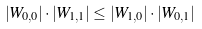<formula> <loc_0><loc_0><loc_500><loc_500>| W _ { 0 , 0 } | \cdot | W _ { 1 , 1 } | \leq | W _ { 1 , 0 } | \cdot | W _ { 0 , 1 } |</formula> 